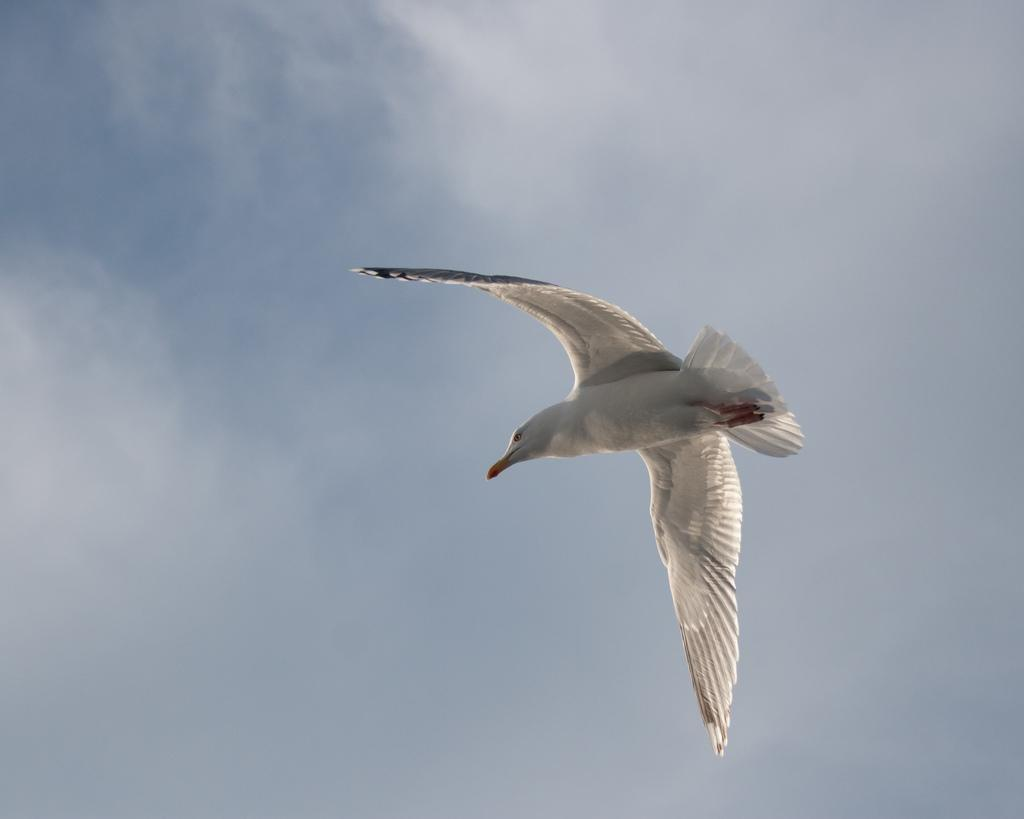What type of animal is in the image? There is a bird in the image. Where is the bird located in the image? The bird is in the air. What can be seen in the background of the image? The sky is visible in the background of the image. What type of education is being taught in the image? There is no reference to education in the image; it features a bird in the air with a visible sky in the background. 